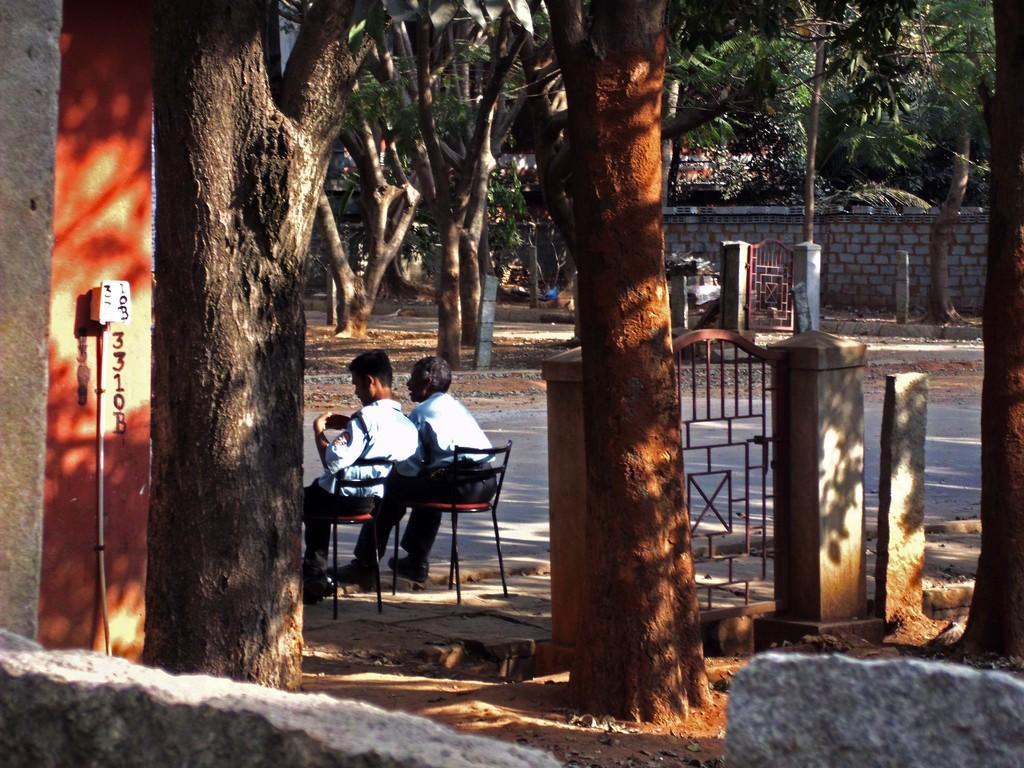Please provide a concise description of this image. In the foreground of this image, there is a wall, few trees and the gate. In the background, there are two men sitting on the chairs, road, poles, trees, wall and another gate. 